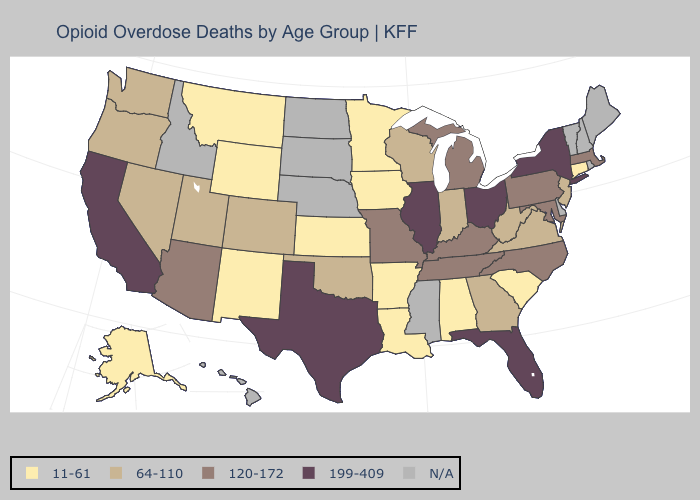Which states have the highest value in the USA?
Short answer required. California, Florida, Illinois, New York, Ohio, Texas. Name the states that have a value in the range 11-61?
Concise answer only. Alabama, Alaska, Arkansas, Connecticut, Iowa, Kansas, Louisiana, Minnesota, Montana, New Mexico, South Carolina, Wyoming. Name the states that have a value in the range 11-61?
Keep it brief. Alabama, Alaska, Arkansas, Connecticut, Iowa, Kansas, Louisiana, Minnesota, Montana, New Mexico, South Carolina, Wyoming. Name the states that have a value in the range 64-110?
Answer briefly. Colorado, Georgia, Indiana, Nevada, New Jersey, Oklahoma, Oregon, Utah, Virginia, Washington, West Virginia, Wisconsin. Which states have the lowest value in the Northeast?
Write a very short answer. Connecticut. Does the first symbol in the legend represent the smallest category?
Be succinct. Yes. Does the first symbol in the legend represent the smallest category?
Give a very brief answer. Yes. Does the first symbol in the legend represent the smallest category?
Write a very short answer. Yes. Is the legend a continuous bar?
Give a very brief answer. No. Name the states that have a value in the range 11-61?
Concise answer only. Alabama, Alaska, Arkansas, Connecticut, Iowa, Kansas, Louisiana, Minnesota, Montana, New Mexico, South Carolina, Wyoming. Name the states that have a value in the range 11-61?
Answer briefly. Alabama, Alaska, Arkansas, Connecticut, Iowa, Kansas, Louisiana, Minnesota, Montana, New Mexico, South Carolina, Wyoming. Does Missouri have the lowest value in the USA?
Answer briefly. No. Does Montana have the lowest value in the USA?
Concise answer only. Yes. What is the lowest value in the Northeast?
Give a very brief answer. 11-61. 